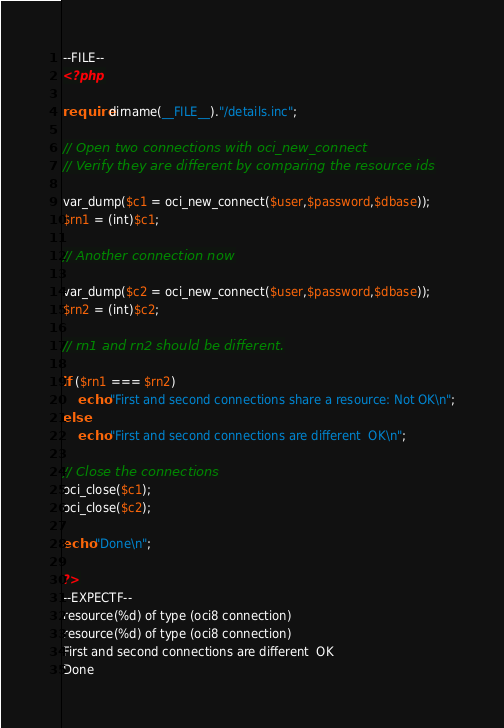Convert code to text. <code><loc_0><loc_0><loc_500><loc_500><_PHP_>--FILE--
<?php

require dirname(__FILE__)."/details.inc";

// Open two connections with oci_new_connect
// Verify they are different by comparing the resource ids

var_dump($c1 = oci_new_connect($user,$password,$dbase));
$rn1 = (int)$c1;

// Another connection now

var_dump($c2 = oci_new_connect($user,$password,$dbase));
$rn2 = (int)$c2;

// rn1 and rn2 should be different.

if ($rn1 === $rn2)
	echo "First and second connections share a resource: Not OK\n";
else
	echo "First and second connections are different  OK\n";

// Close the connections
oci_close($c1);
oci_close($c2);

echo "Done\n";

?>
--EXPECTF--
resource(%d) of type (oci8 connection)
resource(%d) of type (oci8 connection)
First and second connections are different  OK
Done

</code> 